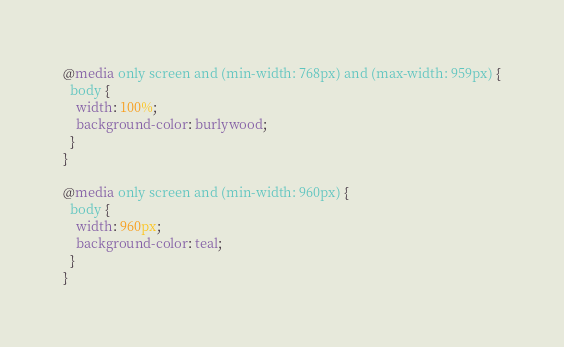<code> <loc_0><loc_0><loc_500><loc_500><_CSS_>
@media only screen and (min-width: 768px) and (max-width: 959px) {
  body {
    width: 100%;
    background-color: burlywood;
  }
}

@media only screen and (min-width: 960px) {
  body {
    width: 960px;
    background-color: teal;
  }
}</code> 